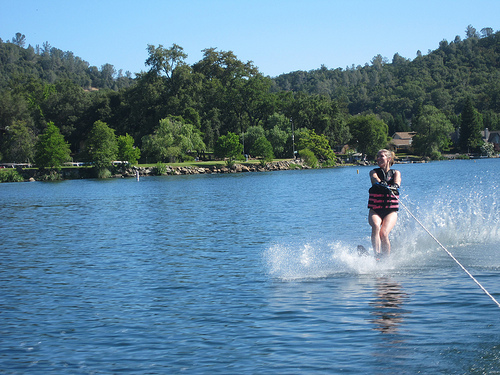Can you describe the environment around the water? The water is surrounded by lush greenery and trees, indicating a tranquil, natural setting that could be a lake or a calm river area. Are there any other water activities visible in the image? No other water activities are visible in the image, although the environment seems suitable for various water sports. 